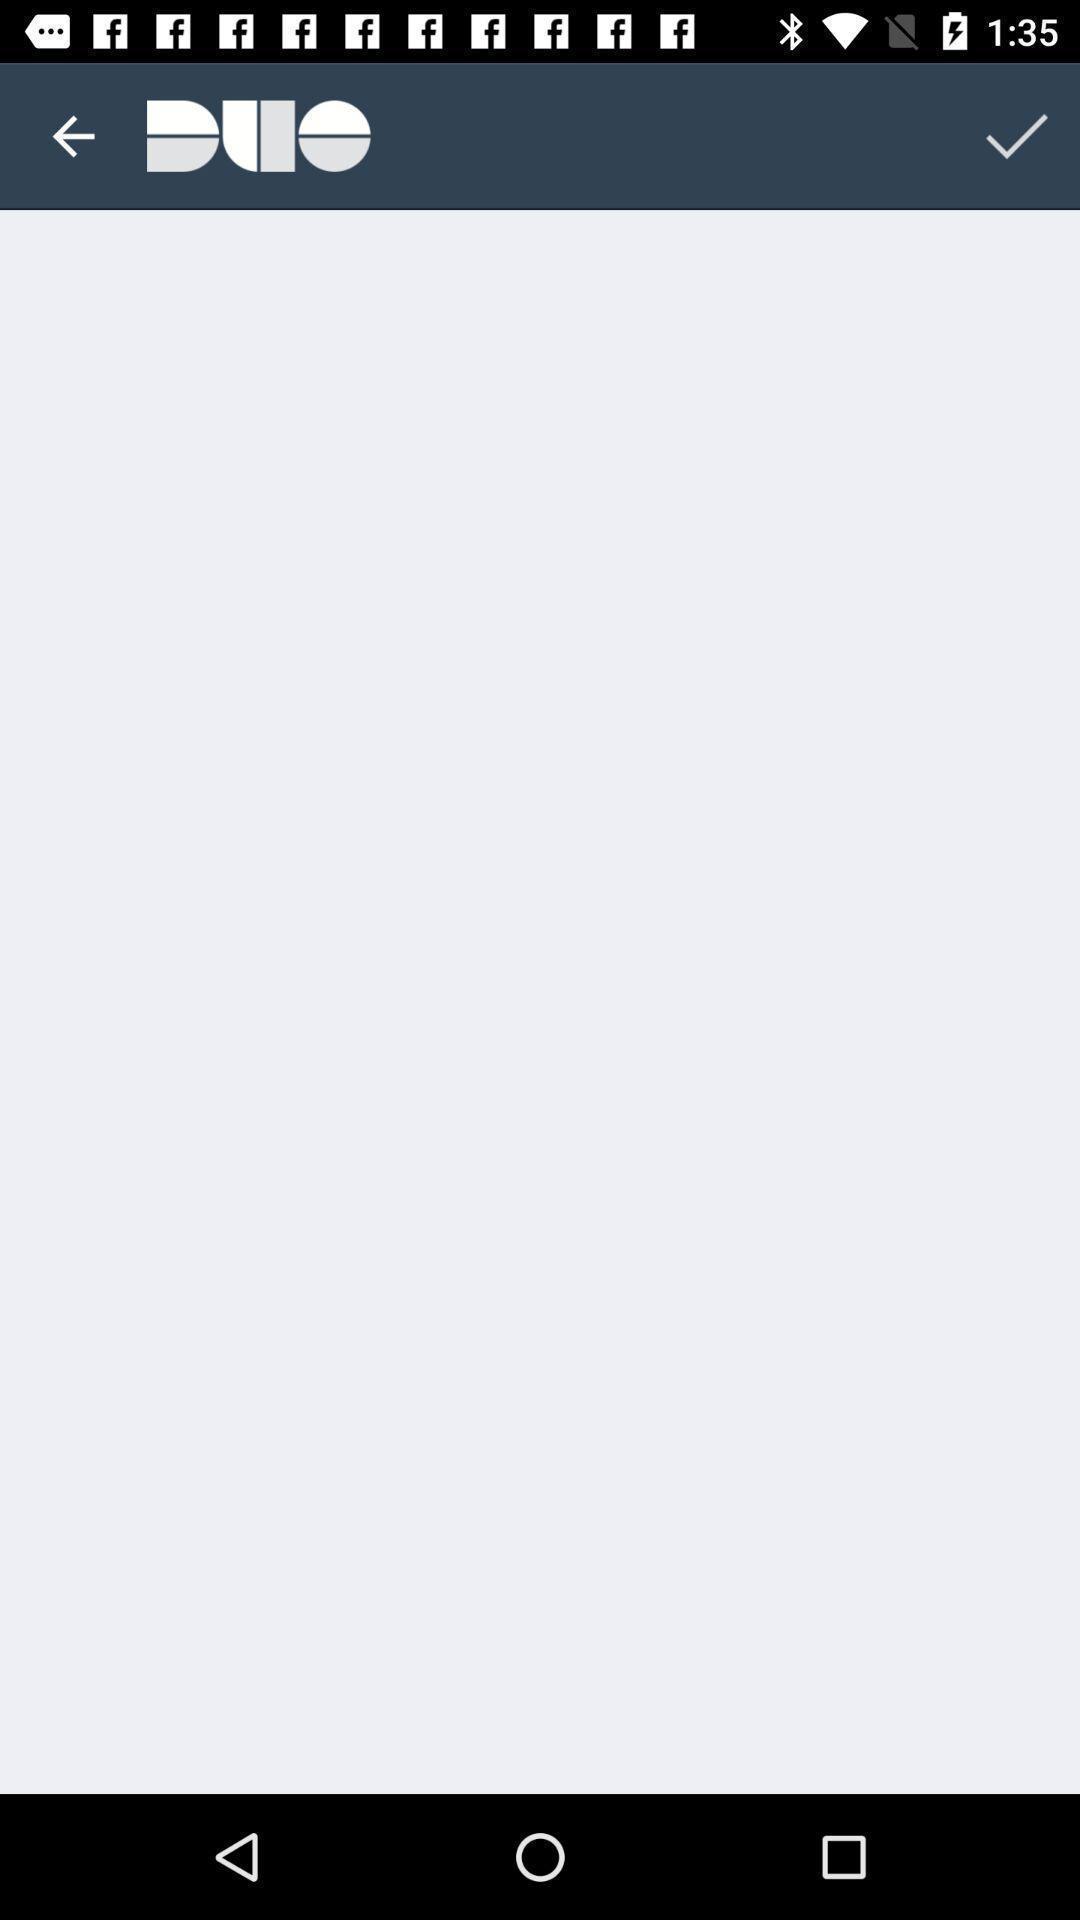Tell me what you see in this picture. Page showing blank page. 